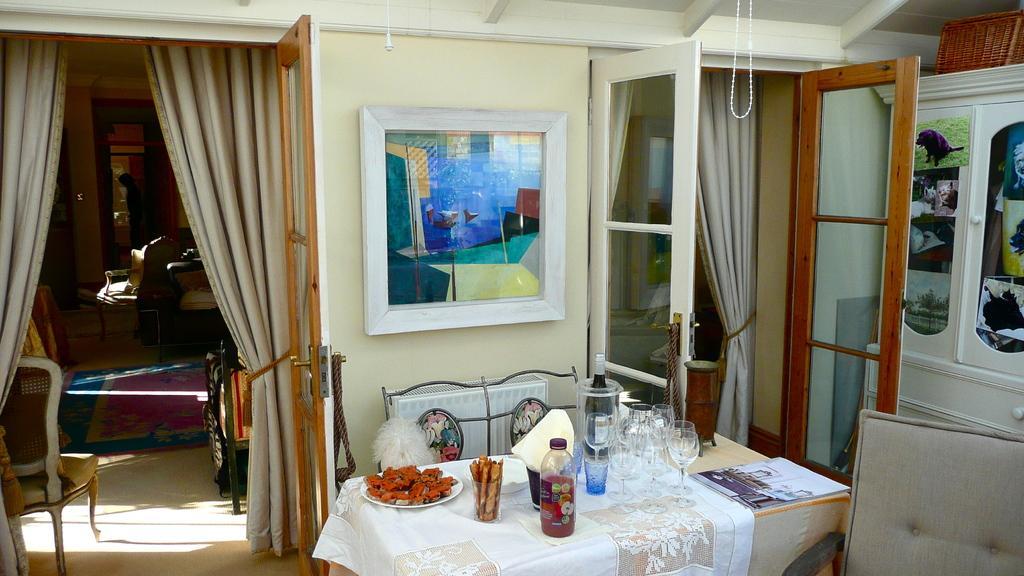Please provide a concise description of this image. This picture describes about a room, at the right side there is a table, on that table there is a white color cloth, there are some glasses and there is a black color wine bottle kept on the table, there is a white color play on the table, there are some chairs, at the right side there is a brown color door, there are white color cupboards, at the left side there is a door and there are two curtains. 